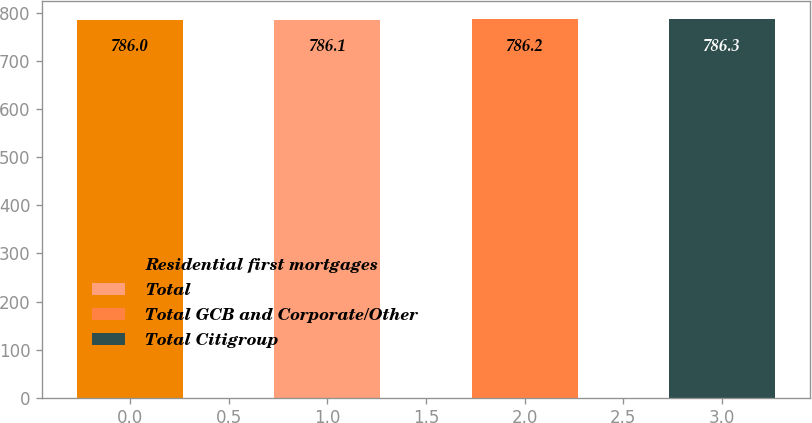Convert chart to OTSL. <chart><loc_0><loc_0><loc_500><loc_500><bar_chart><fcel>Residential first mortgages<fcel>Total<fcel>Total GCB and Corporate/Other<fcel>Total Citigroup<nl><fcel>786<fcel>786.1<fcel>786.2<fcel>786.3<nl></chart> 